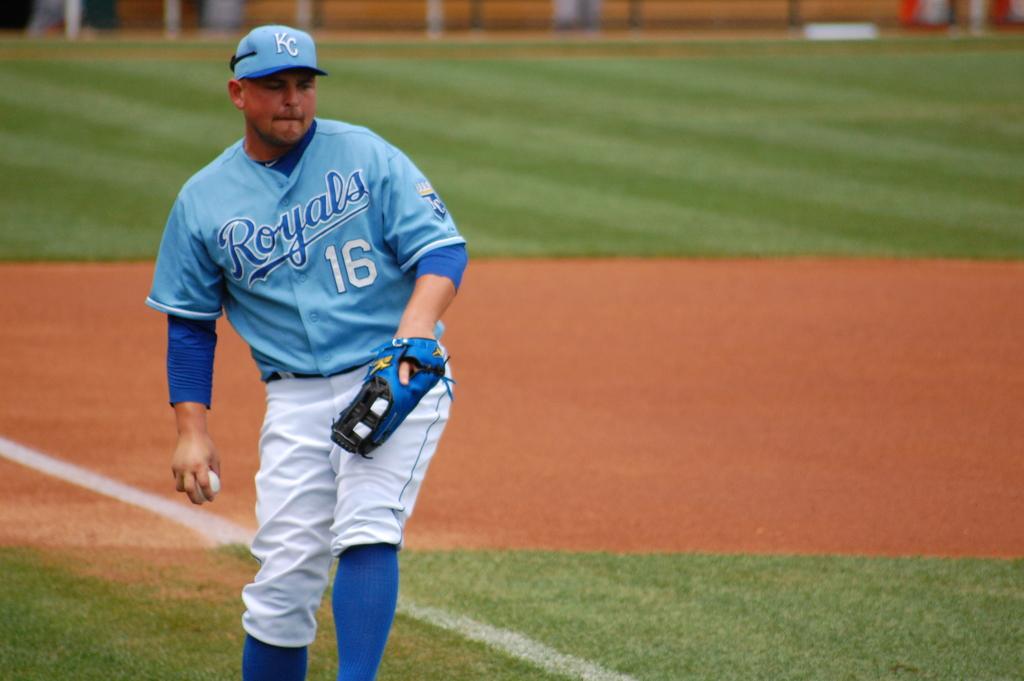What is this players number?
Provide a short and direct response. 16. 